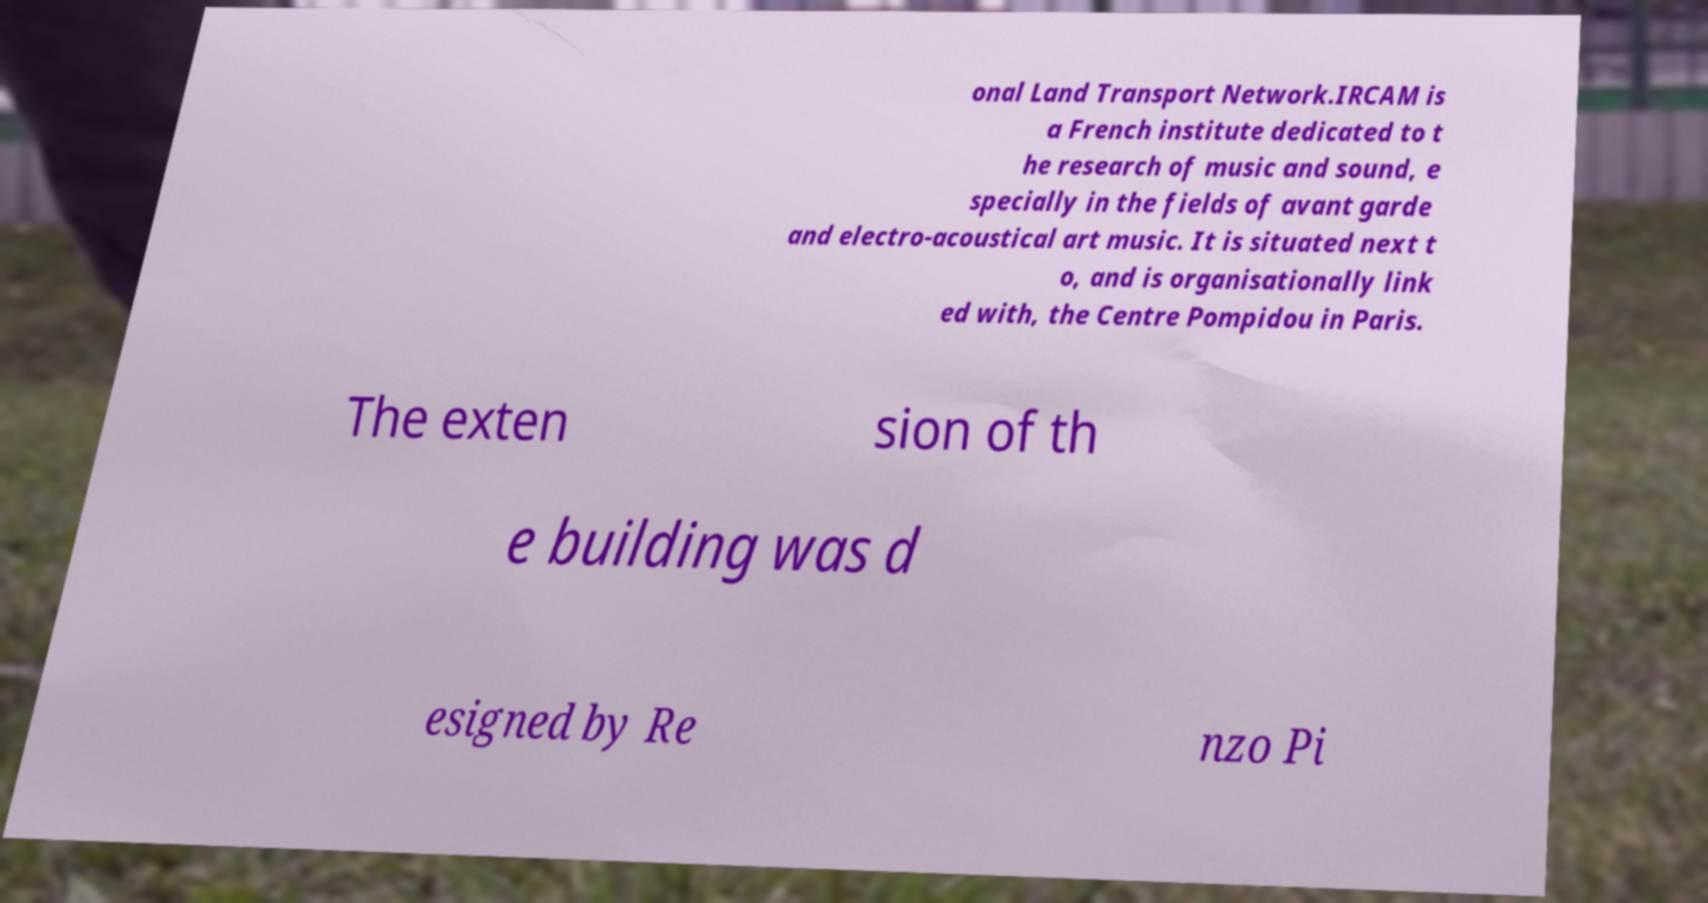For documentation purposes, I need the text within this image transcribed. Could you provide that? onal Land Transport Network.IRCAM is a French institute dedicated to t he research of music and sound, e specially in the fields of avant garde and electro-acoustical art music. It is situated next t o, and is organisationally link ed with, the Centre Pompidou in Paris. The exten sion of th e building was d esigned by Re nzo Pi 